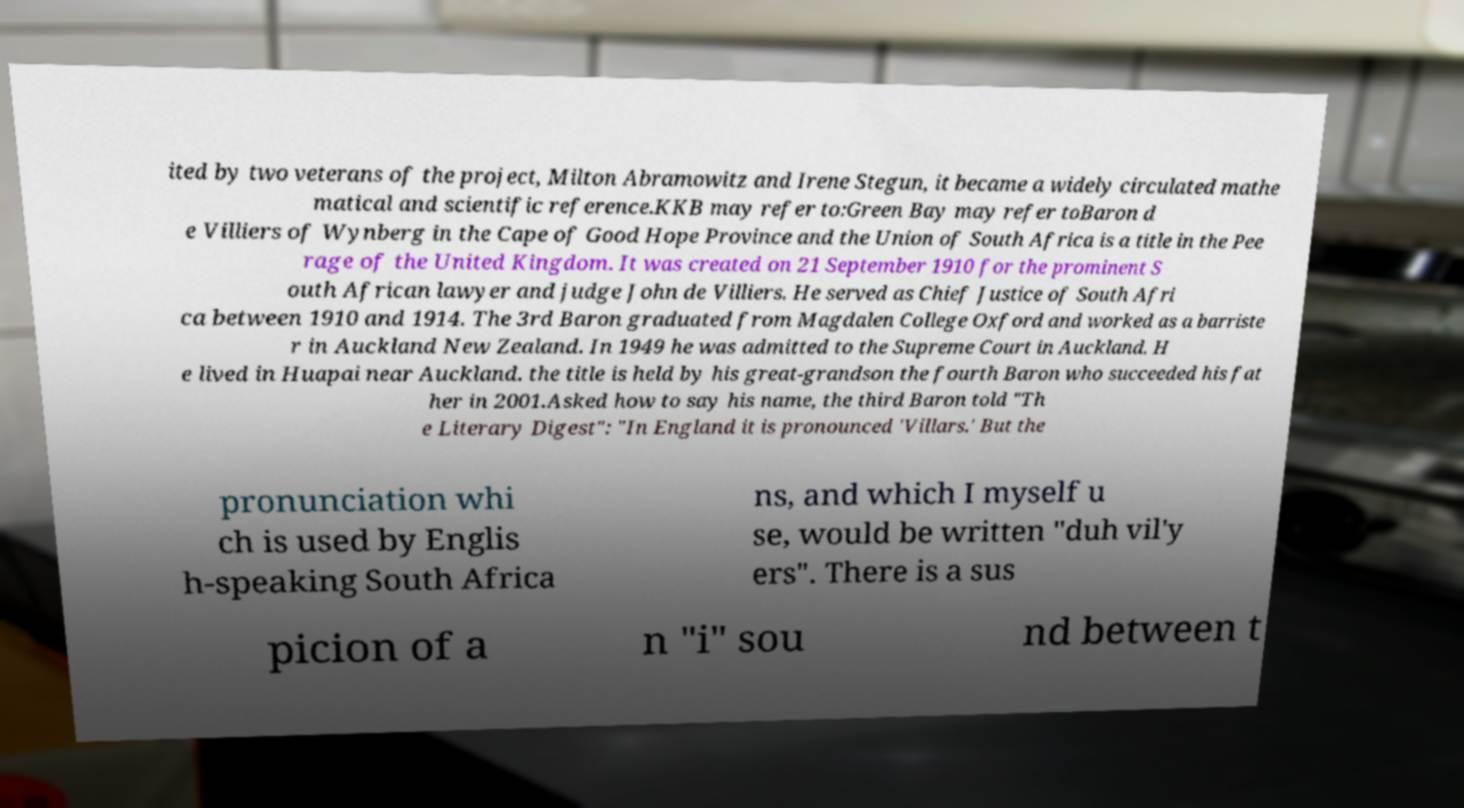Can you accurately transcribe the text from the provided image for me? ited by two veterans of the project, Milton Abramowitz and Irene Stegun, it became a widely circulated mathe matical and scientific reference.KKB may refer to:Green Bay may refer toBaron d e Villiers of Wynberg in the Cape of Good Hope Province and the Union of South Africa is a title in the Pee rage of the United Kingdom. It was created on 21 September 1910 for the prominent S outh African lawyer and judge John de Villiers. He served as Chief Justice of South Afri ca between 1910 and 1914. The 3rd Baron graduated from Magdalen College Oxford and worked as a barriste r in Auckland New Zealand. In 1949 he was admitted to the Supreme Court in Auckland. H e lived in Huapai near Auckland. the title is held by his great-grandson the fourth Baron who succeeded his fat her in 2001.Asked how to say his name, the third Baron told "Th e Literary Digest": "In England it is pronounced 'Villars.' But the pronunciation whi ch is used by Englis h-speaking South Africa ns, and which I myself u se, would be written "duh vil'y ers". There is a sus picion of a n "i" sou nd between t 